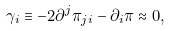<formula> <loc_0><loc_0><loc_500><loc_500>\gamma _ { i } \equiv - 2 \partial ^ { j } \pi _ { j i } - \partial _ { i } \pi \approx 0 ,</formula> 